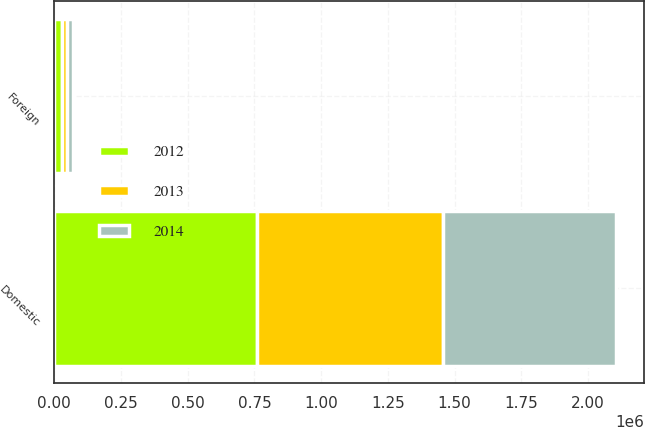<chart> <loc_0><loc_0><loc_500><loc_500><stacked_bar_chart><ecel><fcel>Domestic<fcel>Foreign<nl><fcel>2012<fcel>757896<fcel>29538<nl><fcel>2013<fcel>697062<fcel>16406<nl><fcel>2014<fcel>649098<fcel>25057<nl></chart> 